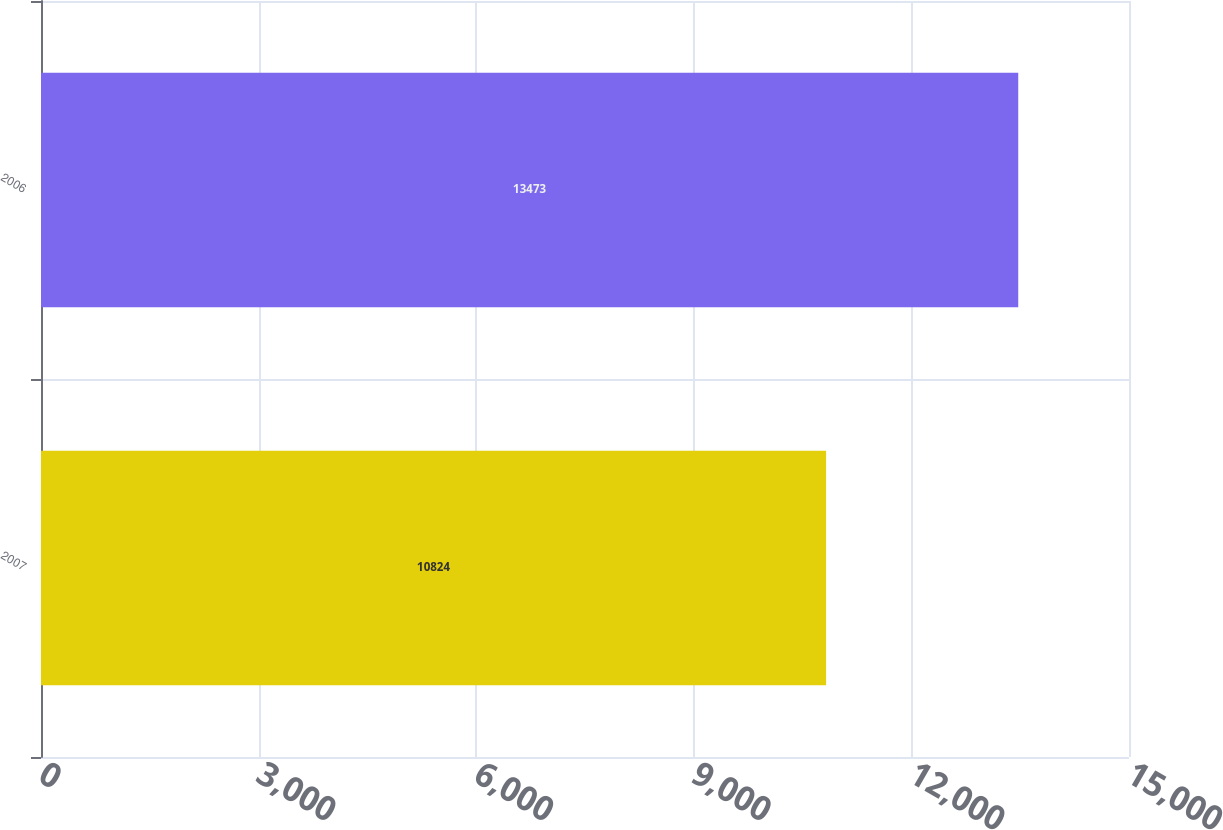Convert chart to OTSL. <chart><loc_0><loc_0><loc_500><loc_500><bar_chart><fcel>2007<fcel>2006<nl><fcel>10824<fcel>13473<nl></chart> 